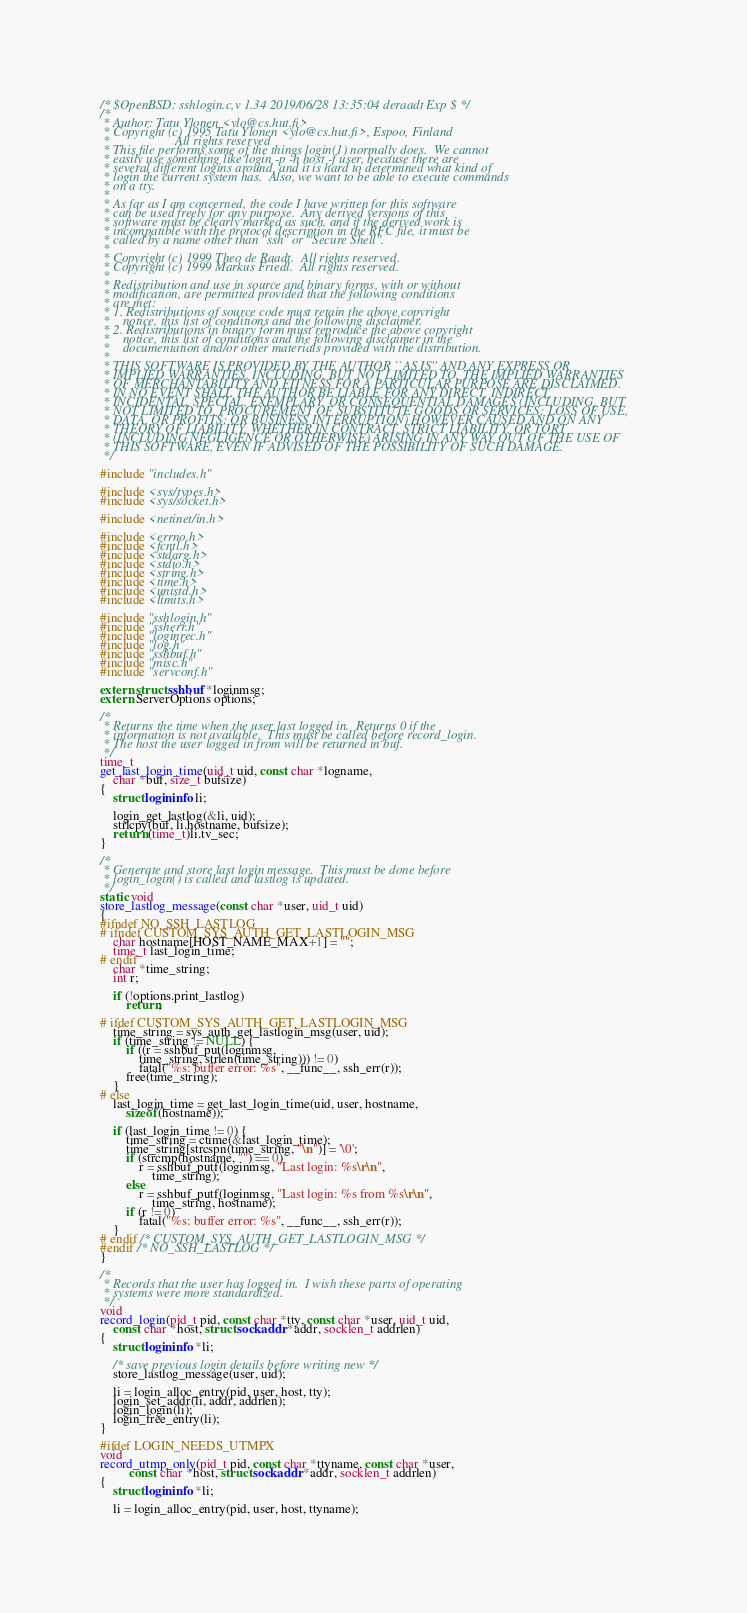<code> <loc_0><loc_0><loc_500><loc_500><_C_>/* $OpenBSD: sshlogin.c,v 1.34 2019/06/28 13:35:04 deraadt Exp $ */
/*
 * Author: Tatu Ylonen <ylo@cs.hut.fi>
 * Copyright (c) 1995 Tatu Ylonen <ylo@cs.hut.fi>, Espoo, Finland
 *                    All rights reserved
 * This file performs some of the things login(1) normally does.  We cannot
 * easily use something like login -p -h host -f user, because there are
 * several different logins around, and it is hard to determined what kind of
 * login the current system has.  Also, we want to be able to execute commands
 * on a tty.
 *
 * As far as I am concerned, the code I have written for this software
 * can be used freely for any purpose.  Any derived versions of this
 * software must be clearly marked as such, and if the derived work is
 * incompatible with the protocol description in the RFC file, it must be
 * called by a name other than "ssh" or "Secure Shell".
 *
 * Copyright (c) 1999 Theo de Raadt.  All rights reserved.
 * Copyright (c) 1999 Markus Friedl.  All rights reserved.
 *
 * Redistribution and use in source and binary forms, with or without
 * modification, are permitted provided that the following conditions
 * are met:
 * 1. Redistributions of source code must retain the above copyright
 *    notice, this list of conditions and the following disclaimer.
 * 2. Redistributions in binary form must reproduce the above copyright
 *    notice, this list of conditions and the following disclaimer in the
 *    documentation and/or other materials provided with the distribution.
 *
 * THIS SOFTWARE IS PROVIDED BY THE AUTHOR ``AS IS'' AND ANY EXPRESS OR
 * IMPLIED WARRANTIES, INCLUDING, BUT NOT LIMITED TO, THE IMPLIED WARRANTIES
 * OF MERCHANTABILITY AND FITNESS FOR A PARTICULAR PURPOSE ARE DISCLAIMED.
 * IN NO EVENT SHALL THE AUTHOR BE LIABLE FOR ANY DIRECT, INDIRECT,
 * INCIDENTAL, SPECIAL, EXEMPLARY, OR CONSEQUENTIAL DAMAGES (INCLUDING, BUT
 * NOT LIMITED TO, PROCUREMENT OF SUBSTITUTE GOODS OR SERVICES; LOSS OF USE,
 * DATA, OR PROFITS; OR BUSINESS INTERRUPTION) HOWEVER CAUSED AND ON ANY
 * THEORY OF LIABILITY, WHETHER IN CONTRACT, STRICT LIABILITY, OR TORT
 * (INCLUDING NEGLIGENCE OR OTHERWISE) ARISING IN ANY WAY OUT OF THE USE OF
 * THIS SOFTWARE, EVEN IF ADVISED OF THE POSSIBILITY OF SUCH DAMAGE.
 */

#include "includes.h"

#include <sys/types.h>
#include <sys/socket.h>

#include <netinet/in.h>

#include <errno.h>
#include <fcntl.h>
#include <stdarg.h>
#include <stdio.h>
#include <string.h>
#include <time.h>
#include <unistd.h>
#include <limits.h>

#include "sshlogin.h"
#include "ssherr.h"
#include "loginrec.h"
#include "log.h"
#include "sshbuf.h"
#include "misc.h"
#include "servconf.h"

extern struct sshbuf *loginmsg;
extern ServerOptions options;

/*
 * Returns the time when the user last logged in.  Returns 0 if the
 * information is not available.  This must be called before record_login.
 * The host the user logged in from will be returned in buf.
 */
time_t
get_last_login_time(uid_t uid, const char *logname,
    char *buf, size_t bufsize)
{
	struct logininfo li;

	login_get_lastlog(&li, uid);
	strlcpy(buf, li.hostname, bufsize);
	return (time_t)li.tv_sec;
}

/*
 * Generate and store last login message.  This must be done before
 * login_login() is called and lastlog is updated.
 */
static void
store_lastlog_message(const char *user, uid_t uid)
{
#ifndef NO_SSH_LASTLOG
# ifndef CUSTOM_SYS_AUTH_GET_LASTLOGIN_MSG
	char hostname[HOST_NAME_MAX+1] = "";
	time_t last_login_time;
# endif
	char *time_string;
	int r;

	if (!options.print_lastlog)
		return;

# ifdef CUSTOM_SYS_AUTH_GET_LASTLOGIN_MSG
	time_string = sys_auth_get_lastlogin_msg(user, uid);
	if (time_string != NULL) {
		if ((r = sshbuf_put(loginmsg,
		    time_string, strlen(time_string))) != 0)
			fatal("%s: buffer error: %s", __func__, ssh_err(r));
		free(time_string);
	}
# else
	last_login_time = get_last_login_time(uid, user, hostname,
	    sizeof(hostname));

	if (last_login_time != 0) {
		time_string = ctime(&last_login_time);
		time_string[strcspn(time_string, "\n")] = '\0';
		if (strcmp(hostname, "") == 0)
			r = sshbuf_putf(loginmsg, "Last login: %s\r\n",
			    time_string);
		else
			r = sshbuf_putf(loginmsg, "Last login: %s from %s\r\n",
			    time_string, hostname);
		if (r != 0)
			fatal("%s: buffer error: %s", __func__, ssh_err(r));
	}
# endif /* CUSTOM_SYS_AUTH_GET_LASTLOGIN_MSG */
#endif /* NO_SSH_LASTLOG */
}

/*
 * Records that the user has logged in.  I wish these parts of operating
 * systems were more standardized.
 */
void
record_login(pid_t pid, const char *tty, const char *user, uid_t uid,
    const char *host, struct sockaddr *addr, socklen_t addrlen)
{
	struct logininfo *li;

	/* save previous login details before writing new */
	store_lastlog_message(user, uid);

	li = login_alloc_entry(pid, user, host, tty);
	login_set_addr(li, addr, addrlen);
	login_login(li);
	login_free_entry(li);
}

#ifdef LOGIN_NEEDS_UTMPX
void
record_utmp_only(pid_t pid, const char *ttyname, const char *user,
		 const char *host, struct sockaddr *addr, socklen_t addrlen)
{
	struct logininfo *li;

	li = login_alloc_entry(pid, user, host, ttyname);</code> 